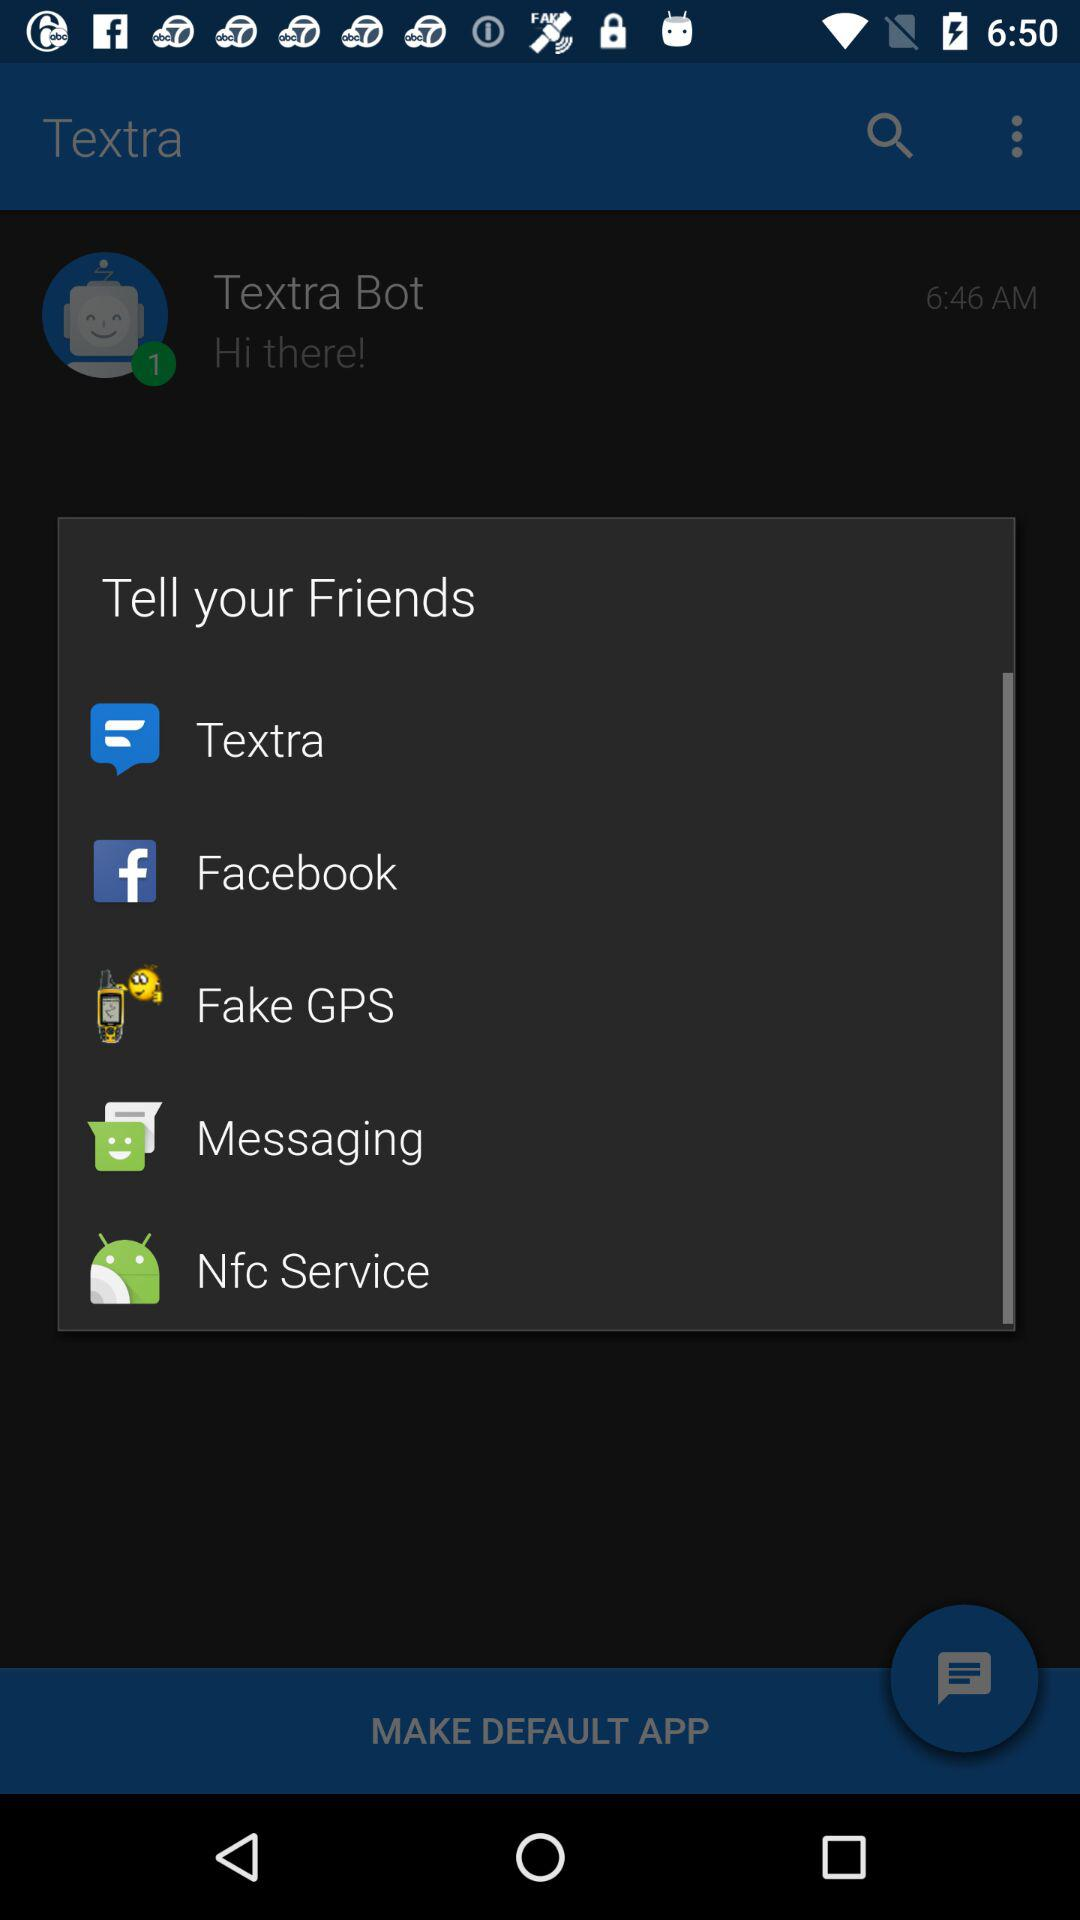What are the options to tell friends? The options are Textra, Facebook, Fake GPS, Messaging and Nfc Service. 